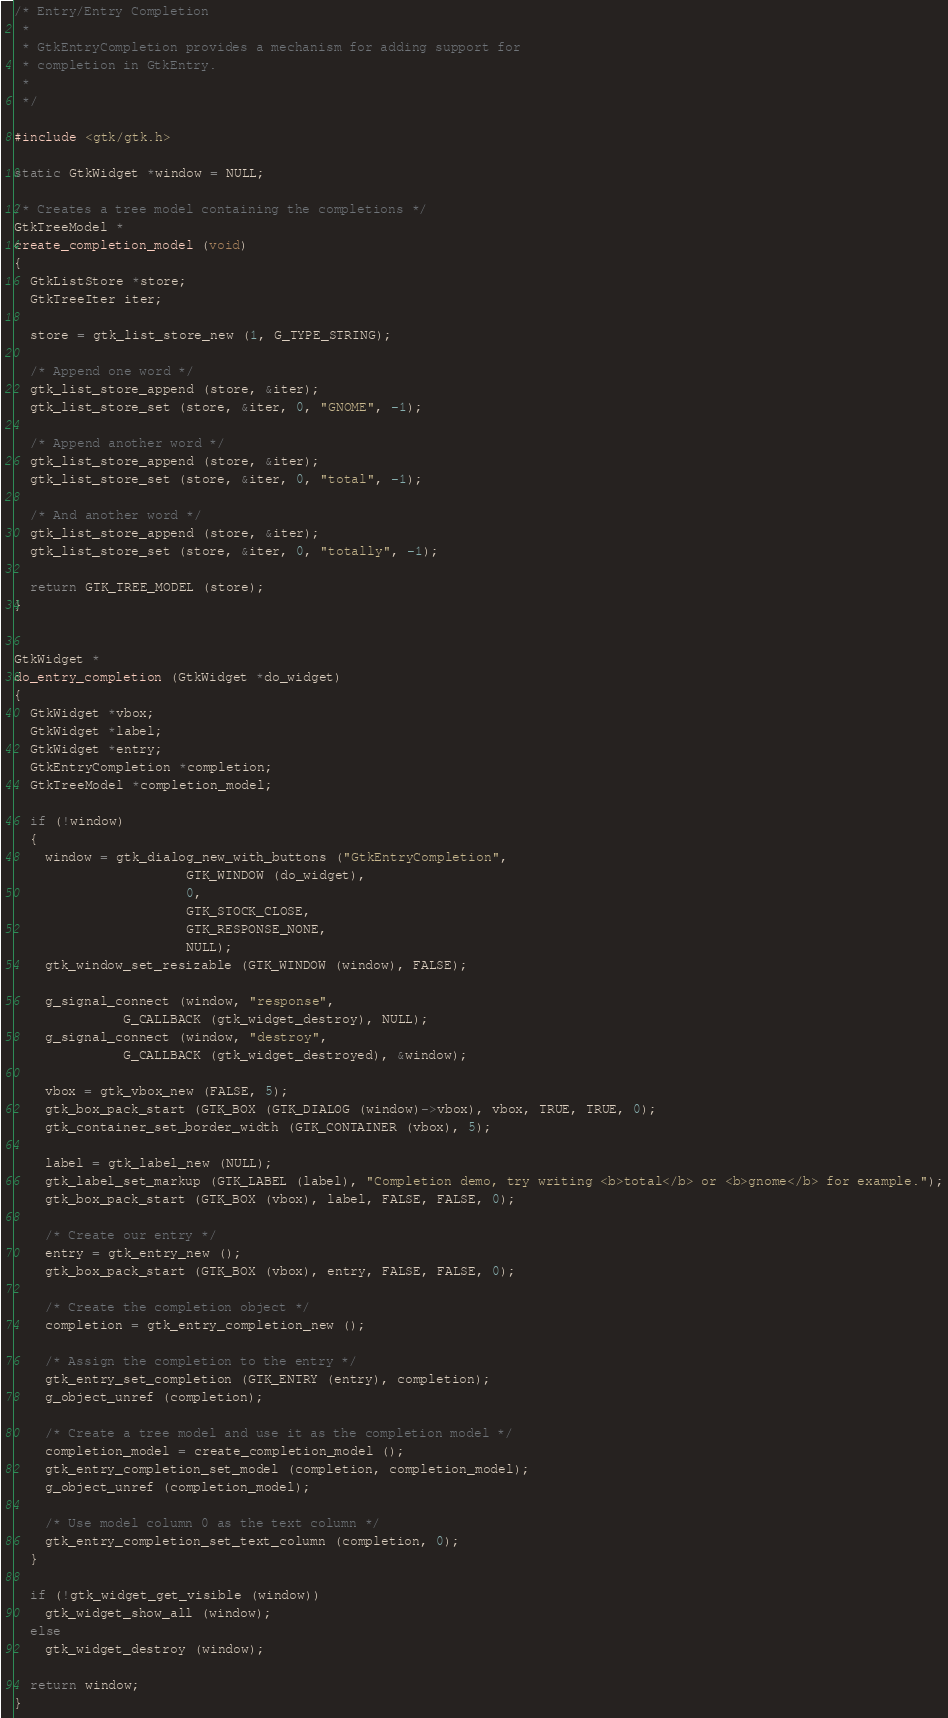<code> <loc_0><loc_0><loc_500><loc_500><_C_>/* Entry/Entry Completion
 *
 * GtkEntryCompletion provides a mechanism for adding support for
 * completion in GtkEntry.
 *
 */

#include <gtk/gtk.h>

static GtkWidget *window = NULL;

/* Creates a tree model containing the completions */
GtkTreeModel *
create_completion_model (void)
{
  GtkListStore *store;
  GtkTreeIter iter;
  
  store = gtk_list_store_new (1, G_TYPE_STRING);

  /* Append one word */
  gtk_list_store_append (store, &iter);
  gtk_list_store_set (store, &iter, 0, "GNOME", -1);

  /* Append another word */
  gtk_list_store_append (store, &iter);
  gtk_list_store_set (store, &iter, 0, "total", -1);

  /* And another word */
  gtk_list_store_append (store, &iter);
  gtk_list_store_set (store, &iter, 0, "totally", -1);
  
  return GTK_TREE_MODEL (store);
}


GtkWidget *
do_entry_completion (GtkWidget *do_widget)
{
  GtkWidget *vbox;
  GtkWidget *label;
  GtkWidget *entry;
  GtkEntryCompletion *completion;
  GtkTreeModel *completion_model;
  
  if (!window)
  {
    window = gtk_dialog_new_with_buttons ("GtkEntryCompletion",
					  GTK_WINDOW (do_widget),
					  0,
					  GTK_STOCK_CLOSE,
					  GTK_RESPONSE_NONE,
					  NULL);
    gtk_window_set_resizable (GTK_WINDOW (window), FALSE);

    g_signal_connect (window, "response",
		      G_CALLBACK (gtk_widget_destroy), NULL);
    g_signal_connect (window, "destroy",
		      G_CALLBACK (gtk_widget_destroyed), &window);

    vbox = gtk_vbox_new (FALSE, 5);
    gtk_box_pack_start (GTK_BOX (GTK_DIALOG (window)->vbox), vbox, TRUE, TRUE, 0);
    gtk_container_set_border_width (GTK_CONTAINER (vbox), 5);

    label = gtk_label_new (NULL);
    gtk_label_set_markup (GTK_LABEL (label), "Completion demo, try writing <b>total</b> or <b>gnome</b> for example.");
    gtk_box_pack_start (GTK_BOX (vbox), label, FALSE, FALSE, 0);

    /* Create our entry */
    entry = gtk_entry_new ();
    gtk_box_pack_start (GTK_BOX (vbox), entry, FALSE, FALSE, 0);

    /* Create the completion object */
    completion = gtk_entry_completion_new ();

    /* Assign the completion to the entry */
    gtk_entry_set_completion (GTK_ENTRY (entry), completion);
    g_object_unref (completion);
    
    /* Create a tree model and use it as the completion model */
    completion_model = create_completion_model ();
    gtk_entry_completion_set_model (completion, completion_model);
    g_object_unref (completion_model);
    
    /* Use model column 0 as the text column */
    gtk_entry_completion_set_text_column (completion, 0);
  }

  if (!gtk_widget_get_visible (window))
    gtk_widget_show_all (window);
  else
    gtk_widget_destroy (window);

  return window;
}


</code> 